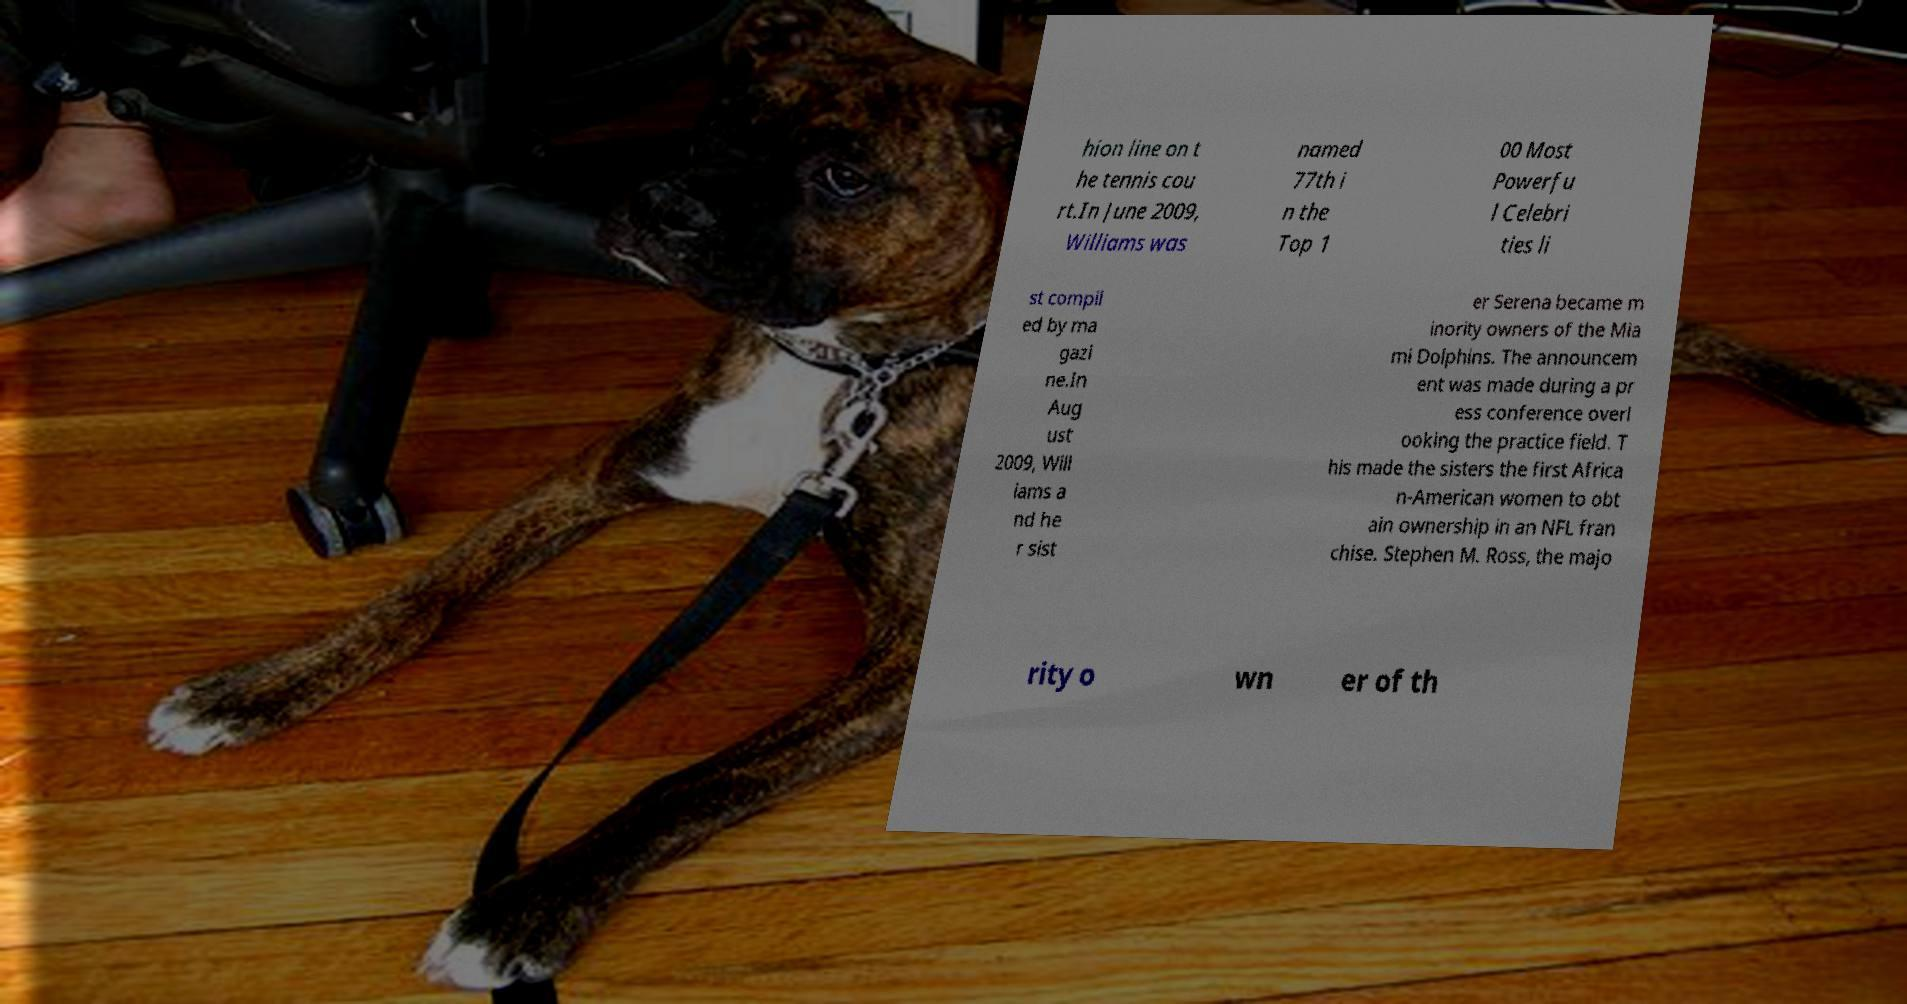Could you assist in decoding the text presented in this image and type it out clearly? hion line on t he tennis cou rt.In June 2009, Williams was named 77th i n the Top 1 00 Most Powerfu l Celebri ties li st compil ed by ma gazi ne.In Aug ust 2009, Will iams a nd he r sist er Serena became m inority owners of the Mia mi Dolphins. The announcem ent was made during a pr ess conference overl ooking the practice field. T his made the sisters the first Africa n-American women to obt ain ownership in an NFL fran chise. Stephen M. Ross, the majo rity o wn er of th 